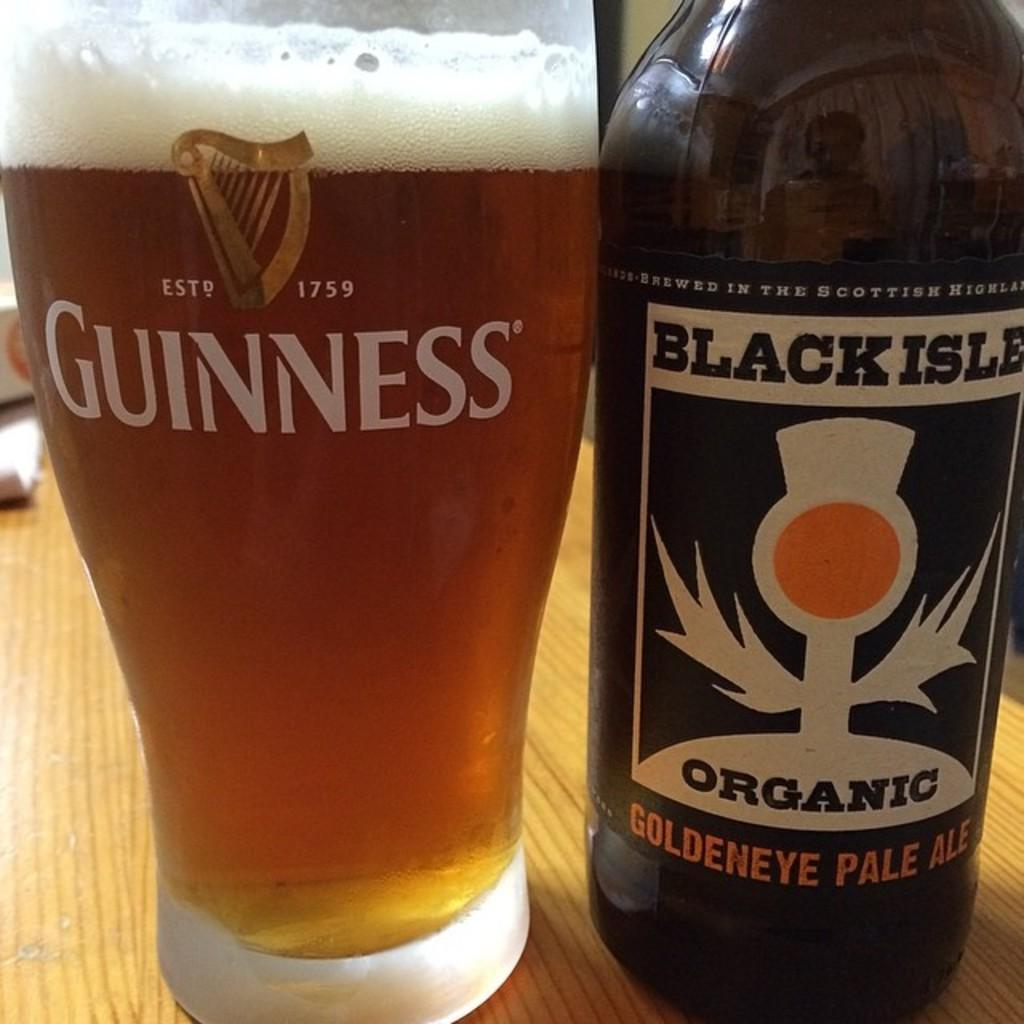Provide a one-sentence caption for the provided image. A pint of beer next to Black Aisle Pale Ale. 